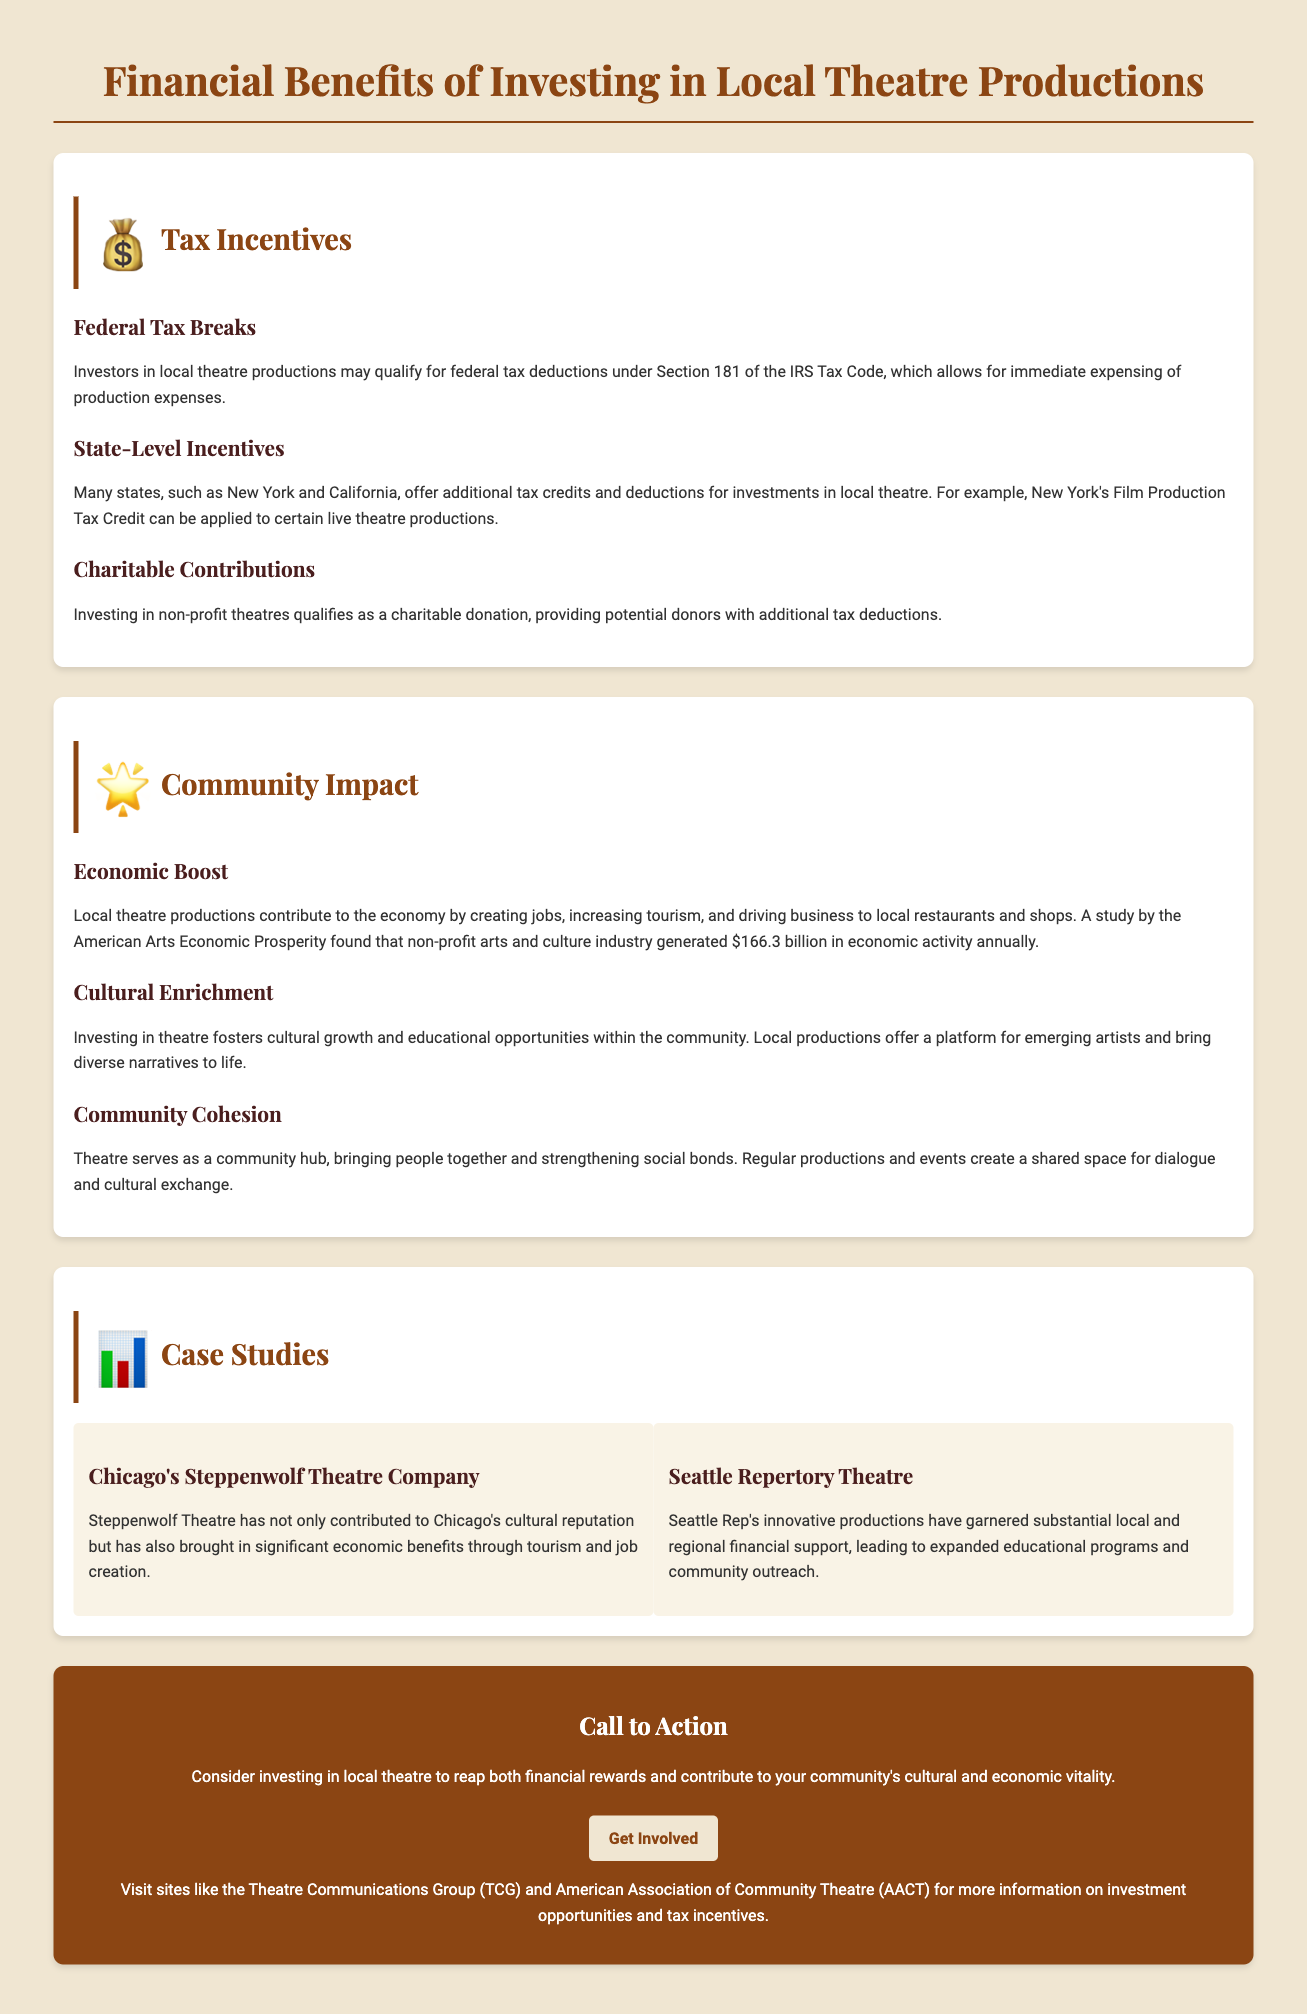What is Section 181 of the IRS Tax Code? Section 181 allows for immediate expensing of production expenses for local theatre production investors.
Answer: immediate expensing Which states offer additional tax credits for local theatre investments? The document mentions New York and California as examples of states providing additional tax credits.
Answer: New York and California What type of donation qualifies for additional tax deductions? Investing in non-profit theatres qualifies as a charitable donation for potential additional tax deductions.
Answer: charitable donation How much economic activity does the non-profit arts and culture industry generate annually? The American Arts Economic Prosperity study indicates the non-profit arts and culture industry generates $166.3 billion in economic activity annually.
Answer: $166.3 billion What are the three main community impacts of investing in theatre? Economic boost, cultural enrichment, and community cohesion are the three main impacts highlighted.
Answer: economic boost, cultural enrichment, community cohesion What is the focus of the case study regarding Steppenwolf Theatre Company? It discusses Steppenwolf Theatre's contribution to Chicago's cultural reputation and economic benefits.
Answer: cultural reputation and economic benefits What additional programs did Seattle Repertory Theatre expand? Seattle Rep expanded educational programs and community outreach as a result of financial support.
Answer: educational programs and community outreach What is the call to action mentioned in the document? The call to action encourages readers to invest in local theatre for financial rewards and community contribution.
Answer: invest in local theatre Where can more information on investment opportunities be found? The document suggests visiting the Theatre Communications Group (TCG) and American Association of Community Theatre (AACT) for investment opportunities.
Answer: Theatre Communications Group (TCG) and American Association of Community Theatre (AACT) 